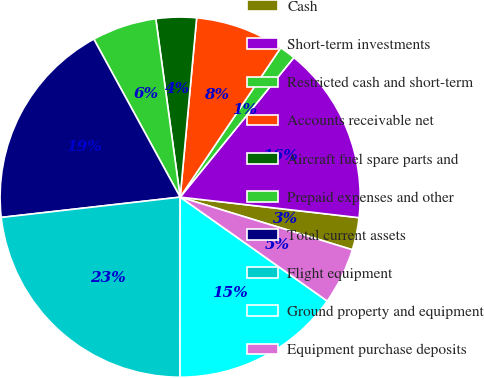Convert chart to OTSL. <chart><loc_0><loc_0><loc_500><loc_500><pie_chart><fcel>Cash<fcel>Short-term investments<fcel>Restricted cash and short-term<fcel>Accounts receivable net<fcel>Aircraft fuel spare parts and<fcel>Prepaid expenses and other<fcel>Total current assets<fcel>Flight equipment<fcel>Ground property and equipment<fcel>Equipment purchase deposits<nl><fcel>2.9%<fcel>15.94%<fcel>1.45%<fcel>7.97%<fcel>3.62%<fcel>5.8%<fcel>18.84%<fcel>23.19%<fcel>15.22%<fcel>5.07%<nl></chart> 